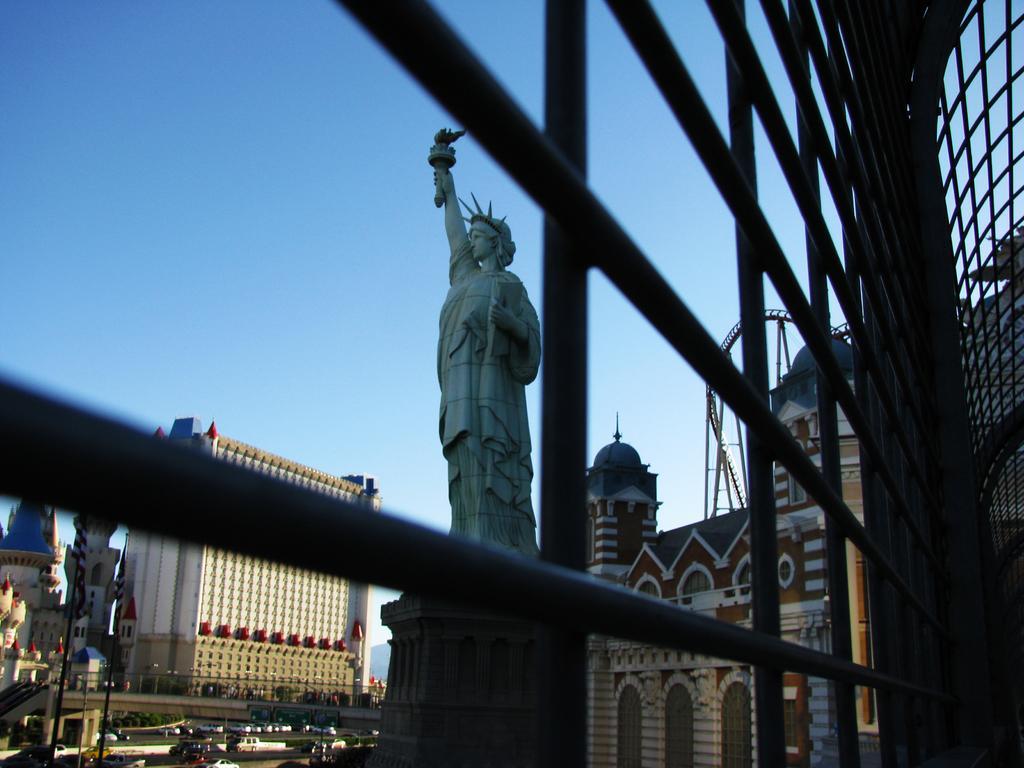Can you describe this image briefly? In the foreground of the image we can see the road and some vehicles. In the middle of the image we can see iron rods, big buildings and statue of liberty. On the top of the image we can see the sky and iron rods. 